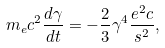Convert formula to latex. <formula><loc_0><loc_0><loc_500><loc_500>m _ { e } c ^ { 2 } \frac { d \gamma } { d t } = - \frac { 2 } { 3 } \gamma ^ { 4 } \frac { e ^ { 2 } c } { s ^ { 2 } } ,</formula> 